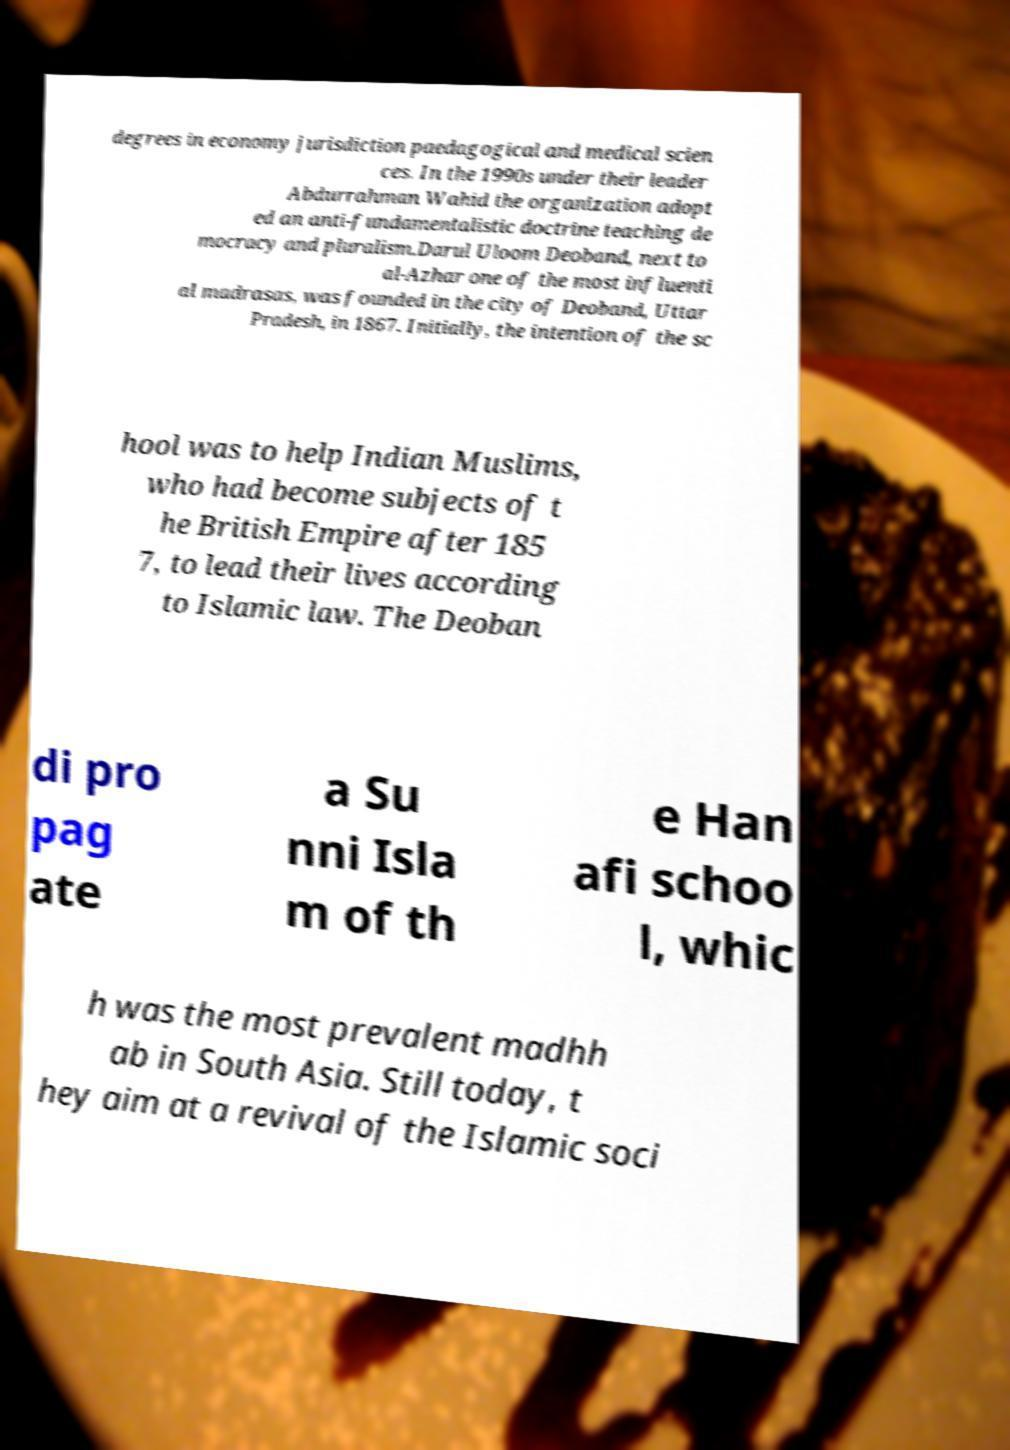I need the written content from this picture converted into text. Can you do that? degrees in economy jurisdiction paedagogical and medical scien ces. In the 1990s under their leader Abdurrahman Wahid the organization adopt ed an anti-fundamentalistic doctrine teaching de mocracy and pluralism.Darul Uloom Deoband, next to al-Azhar one of the most influenti al madrasas, was founded in the city of Deoband, Uttar Pradesh, in 1867. Initially, the intention of the sc hool was to help Indian Muslims, who had become subjects of t he British Empire after 185 7, to lead their lives according to Islamic law. The Deoban di pro pag ate a Su nni Isla m of th e Han afi schoo l, whic h was the most prevalent madhh ab in South Asia. Still today, t hey aim at a revival of the Islamic soci 